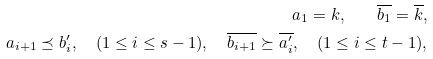Convert formula to latex. <formula><loc_0><loc_0><loc_500><loc_500>a _ { 1 } = k , \quad \overline { b _ { 1 } } = \overline { k } , \\ a _ { i + 1 } \preceq b ^ { \prime } _ { i } , \quad ( 1 \leq i \leq s - 1 ) , \quad \overline { b _ { i + 1 } } \succeq \overline { a ^ { \prime } _ { i } } , \quad ( 1 \leq i \leq t - 1 ) ,</formula> 